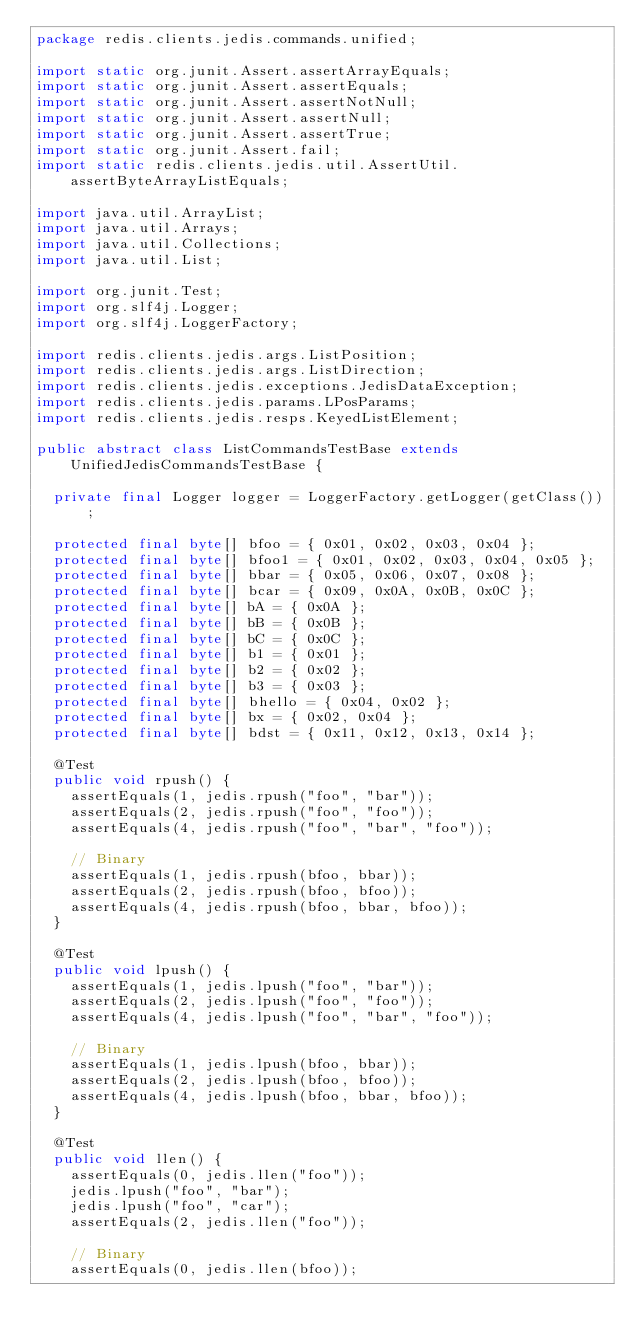Convert code to text. <code><loc_0><loc_0><loc_500><loc_500><_Java_>package redis.clients.jedis.commands.unified;

import static org.junit.Assert.assertArrayEquals;
import static org.junit.Assert.assertEquals;
import static org.junit.Assert.assertNotNull;
import static org.junit.Assert.assertNull;
import static org.junit.Assert.assertTrue;
import static org.junit.Assert.fail;
import static redis.clients.jedis.util.AssertUtil.assertByteArrayListEquals;

import java.util.ArrayList;
import java.util.Arrays;
import java.util.Collections;
import java.util.List;

import org.junit.Test;
import org.slf4j.Logger;
import org.slf4j.LoggerFactory;

import redis.clients.jedis.args.ListPosition;
import redis.clients.jedis.args.ListDirection;
import redis.clients.jedis.exceptions.JedisDataException;
import redis.clients.jedis.params.LPosParams;
import redis.clients.jedis.resps.KeyedListElement;

public abstract class ListCommandsTestBase extends UnifiedJedisCommandsTestBase {

  private final Logger logger = LoggerFactory.getLogger(getClass());

  protected final byte[] bfoo = { 0x01, 0x02, 0x03, 0x04 };
  protected final byte[] bfoo1 = { 0x01, 0x02, 0x03, 0x04, 0x05 };
  protected final byte[] bbar = { 0x05, 0x06, 0x07, 0x08 };
  protected final byte[] bcar = { 0x09, 0x0A, 0x0B, 0x0C };
  protected final byte[] bA = { 0x0A };
  protected final byte[] bB = { 0x0B };
  protected final byte[] bC = { 0x0C };
  protected final byte[] b1 = { 0x01 };
  protected final byte[] b2 = { 0x02 };
  protected final byte[] b3 = { 0x03 };
  protected final byte[] bhello = { 0x04, 0x02 };
  protected final byte[] bx = { 0x02, 0x04 };
  protected final byte[] bdst = { 0x11, 0x12, 0x13, 0x14 };

  @Test
  public void rpush() {
    assertEquals(1, jedis.rpush("foo", "bar"));
    assertEquals(2, jedis.rpush("foo", "foo"));
    assertEquals(4, jedis.rpush("foo", "bar", "foo"));

    // Binary
    assertEquals(1, jedis.rpush(bfoo, bbar));
    assertEquals(2, jedis.rpush(bfoo, bfoo));
    assertEquals(4, jedis.rpush(bfoo, bbar, bfoo));
  }

  @Test
  public void lpush() {
    assertEquals(1, jedis.lpush("foo", "bar"));
    assertEquals(2, jedis.lpush("foo", "foo"));
    assertEquals(4, jedis.lpush("foo", "bar", "foo"));

    // Binary
    assertEquals(1, jedis.lpush(bfoo, bbar));
    assertEquals(2, jedis.lpush(bfoo, bfoo));
    assertEquals(4, jedis.lpush(bfoo, bbar, bfoo));
  }

  @Test
  public void llen() {
    assertEquals(0, jedis.llen("foo"));
    jedis.lpush("foo", "bar");
    jedis.lpush("foo", "car");
    assertEquals(2, jedis.llen("foo"));

    // Binary
    assertEquals(0, jedis.llen(bfoo));</code> 